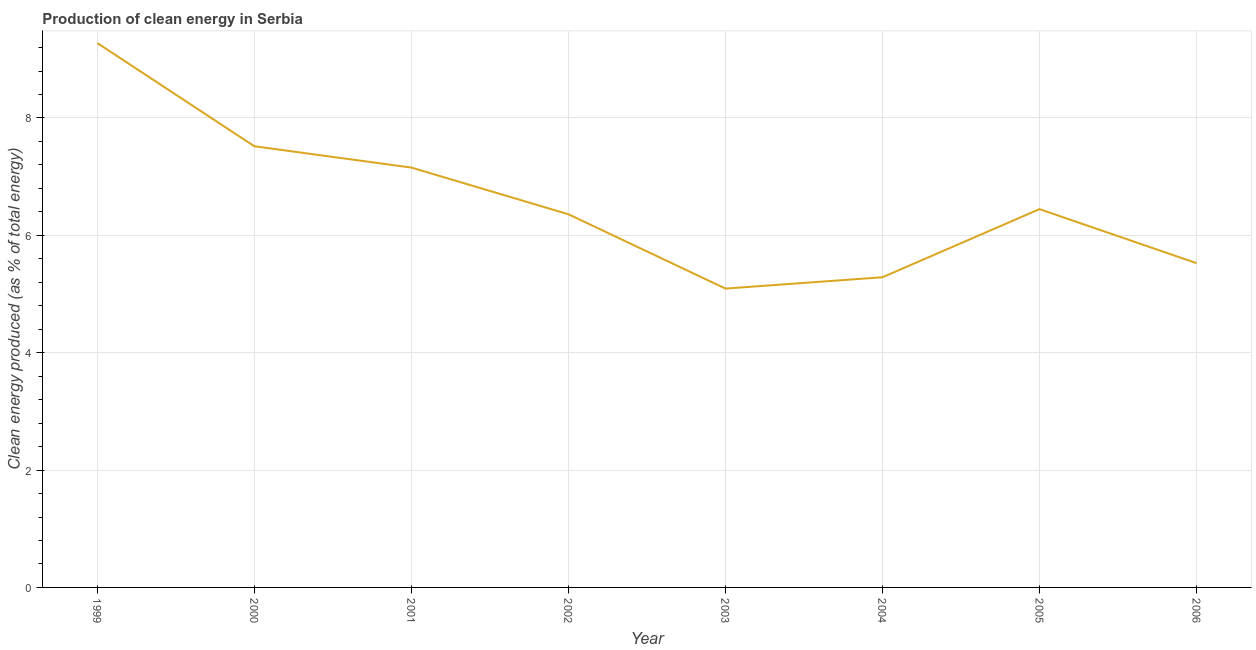What is the production of clean energy in 2002?
Your answer should be compact. 6.36. Across all years, what is the maximum production of clean energy?
Keep it short and to the point. 9.28. Across all years, what is the minimum production of clean energy?
Offer a very short reply. 5.09. In which year was the production of clean energy minimum?
Provide a succinct answer. 2003. What is the sum of the production of clean energy?
Your answer should be compact. 52.66. What is the difference between the production of clean energy in 2001 and 2006?
Make the answer very short. 1.63. What is the average production of clean energy per year?
Provide a succinct answer. 6.58. What is the median production of clean energy?
Your answer should be compact. 6.4. In how many years, is the production of clean energy greater than 5.2 %?
Provide a succinct answer. 7. What is the ratio of the production of clean energy in 2003 to that in 2006?
Your response must be concise. 0.92. What is the difference between the highest and the second highest production of clean energy?
Provide a succinct answer. 1.76. Is the sum of the production of clean energy in 1999 and 2002 greater than the maximum production of clean energy across all years?
Make the answer very short. Yes. What is the difference between the highest and the lowest production of clean energy?
Ensure brevity in your answer.  4.18. In how many years, is the production of clean energy greater than the average production of clean energy taken over all years?
Provide a short and direct response. 3. Does the graph contain any zero values?
Your response must be concise. No. Does the graph contain grids?
Offer a terse response. Yes. What is the title of the graph?
Your answer should be very brief. Production of clean energy in Serbia. What is the label or title of the Y-axis?
Make the answer very short. Clean energy produced (as % of total energy). What is the Clean energy produced (as % of total energy) in 1999?
Make the answer very short. 9.28. What is the Clean energy produced (as % of total energy) of 2000?
Offer a terse response. 7.52. What is the Clean energy produced (as % of total energy) of 2001?
Keep it short and to the point. 7.15. What is the Clean energy produced (as % of total energy) in 2002?
Provide a succinct answer. 6.36. What is the Clean energy produced (as % of total energy) in 2003?
Provide a succinct answer. 5.09. What is the Clean energy produced (as % of total energy) in 2004?
Your answer should be compact. 5.29. What is the Clean energy produced (as % of total energy) in 2005?
Provide a short and direct response. 6.45. What is the Clean energy produced (as % of total energy) of 2006?
Your answer should be compact. 5.53. What is the difference between the Clean energy produced (as % of total energy) in 1999 and 2000?
Provide a succinct answer. 1.76. What is the difference between the Clean energy produced (as % of total energy) in 1999 and 2001?
Ensure brevity in your answer.  2.12. What is the difference between the Clean energy produced (as % of total energy) in 1999 and 2002?
Your answer should be compact. 2.92. What is the difference between the Clean energy produced (as % of total energy) in 1999 and 2003?
Your answer should be very brief. 4.18. What is the difference between the Clean energy produced (as % of total energy) in 1999 and 2004?
Give a very brief answer. 3.99. What is the difference between the Clean energy produced (as % of total energy) in 1999 and 2005?
Provide a short and direct response. 2.83. What is the difference between the Clean energy produced (as % of total energy) in 1999 and 2006?
Provide a short and direct response. 3.75. What is the difference between the Clean energy produced (as % of total energy) in 2000 and 2001?
Offer a very short reply. 0.36. What is the difference between the Clean energy produced (as % of total energy) in 2000 and 2002?
Provide a succinct answer. 1.16. What is the difference between the Clean energy produced (as % of total energy) in 2000 and 2003?
Your response must be concise. 2.43. What is the difference between the Clean energy produced (as % of total energy) in 2000 and 2004?
Offer a terse response. 2.23. What is the difference between the Clean energy produced (as % of total energy) in 2000 and 2005?
Make the answer very short. 1.07. What is the difference between the Clean energy produced (as % of total energy) in 2000 and 2006?
Make the answer very short. 1.99. What is the difference between the Clean energy produced (as % of total energy) in 2001 and 2002?
Your answer should be compact. 0.8. What is the difference between the Clean energy produced (as % of total energy) in 2001 and 2003?
Provide a succinct answer. 2.06. What is the difference between the Clean energy produced (as % of total energy) in 2001 and 2004?
Keep it short and to the point. 1.87. What is the difference between the Clean energy produced (as % of total energy) in 2001 and 2005?
Your response must be concise. 0.71. What is the difference between the Clean energy produced (as % of total energy) in 2001 and 2006?
Offer a very short reply. 1.63. What is the difference between the Clean energy produced (as % of total energy) in 2002 and 2003?
Make the answer very short. 1.27. What is the difference between the Clean energy produced (as % of total energy) in 2002 and 2004?
Make the answer very short. 1.07. What is the difference between the Clean energy produced (as % of total energy) in 2002 and 2005?
Provide a succinct answer. -0.09. What is the difference between the Clean energy produced (as % of total energy) in 2002 and 2006?
Make the answer very short. 0.83. What is the difference between the Clean energy produced (as % of total energy) in 2003 and 2004?
Your answer should be compact. -0.19. What is the difference between the Clean energy produced (as % of total energy) in 2003 and 2005?
Your response must be concise. -1.35. What is the difference between the Clean energy produced (as % of total energy) in 2003 and 2006?
Offer a very short reply. -0.43. What is the difference between the Clean energy produced (as % of total energy) in 2004 and 2005?
Ensure brevity in your answer.  -1.16. What is the difference between the Clean energy produced (as % of total energy) in 2004 and 2006?
Offer a very short reply. -0.24. What is the difference between the Clean energy produced (as % of total energy) in 2005 and 2006?
Provide a succinct answer. 0.92. What is the ratio of the Clean energy produced (as % of total energy) in 1999 to that in 2000?
Offer a very short reply. 1.23. What is the ratio of the Clean energy produced (as % of total energy) in 1999 to that in 2001?
Ensure brevity in your answer.  1.3. What is the ratio of the Clean energy produced (as % of total energy) in 1999 to that in 2002?
Keep it short and to the point. 1.46. What is the ratio of the Clean energy produced (as % of total energy) in 1999 to that in 2003?
Offer a very short reply. 1.82. What is the ratio of the Clean energy produced (as % of total energy) in 1999 to that in 2004?
Make the answer very short. 1.75. What is the ratio of the Clean energy produced (as % of total energy) in 1999 to that in 2005?
Your answer should be compact. 1.44. What is the ratio of the Clean energy produced (as % of total energy) in 1999 to that in 2006?
Ensure brevity in your answer.  1.68. What is the ratio of the Clean energy produced (as % of total energy) in 2000 to that in 2001?
Offer a very short reply. 1.05. What is the ratio of the Clean energy produced (as % of total energy) in 2000 to that in 2002?
Offer a very short reply. 1.18. What is the ratio of the Clean energy produced (as % of total energy) in 2000 to that in 2003?
Provide a short and direct response. 1.48. What is the ratio of the Clean energy produced (as % of total energy) in 2000 to that in 2004?
Provide a succinct answer. 1.42. What is the ratio of the Clean energy produced (as % of total energy) in 2000 to that in 2005?
Keep it short and to the point. 1.17. What is the ratio of the Clean energy produced (as % of total energy) in 2000 to that in 2006?
Make the answer very short. 1.36. What is the ratio of the Clean energy produced (as % of total energy) in 2001 to that in 2002?
Provide a succinct answer. 1.12. What is the ratio of the Clean energy produced (as % of total energy) in 2001 to that in 2003?
Offer a terse response. 1.41. What is the ratio of the Clean energy produced (as % of total energy) in 2001 to that in 2004?
Provide a succinct answer. 1.35. What is the ratio of the Clean energy produced (as % of total energy) in 2001 to that in 2005?
Offer a terse response. 1.11. What is the ratio of the Clean energy produced (as % of total energy) in 2001 to that in 2006?
Your response must be concise. 1.29. What is the ratio of the Clean energy produced (as % of total energy) in 2002 to that in 2003?
Give a very brief answer. 1.25. What is the ratio of the Clean energy produced (as % of total energy) in 2002 to that in 2004?
Keep it short and to the point. 1.2. What is the ratio of the Clean energy produced (as % of total energy) in 2002 to that in 2006?
Provide a short and direct response. 1.15. What is the ratio of the Clean energy produced (as % of total energy) in 2003 to that in 2004?
Give a very brief answer. 0.96. What is the ratio of the Clean energy produced (as % of total energy) in 2003 to that in 2005?
Your answer should be compact. 0.79. What is the ratio of the Clean energy produced (as % of total energy) in 2003 to that in 2006?
Your answer should be very brief. 0.92. What is the ratio of the Clean energy produced (as % of total energy) in 2004 to that in 2005?
Provide a succinct answer. 0.82. What is the ratio of the Clean energy produced (as % of total energy) in 2005 to that in 2006?
Your answer should be very brief. 1.17. 